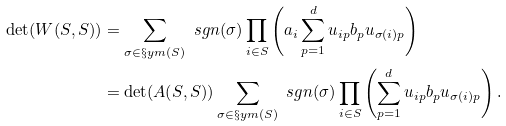Convert formula to latex. <formula><loc_0><loc_0><loc_500><loc_500>\det ( W ( S , S ) ) & = \sum _ { \sigma \in \S y m ( S ) } \ s g n ( \sigma ) \prod _ { i \in S } \left ( a _ { i } \sum _ { p = 1 } ^ { d } u _ { i p } b _ { p } u _ { \sigma ( i ) p } \right ) \\ & = \det ( A ( S , S ) ) \sum _ { \sigma \in \S y m ( S ) } \ s g n ( \sigma ) \prod _ { i \in S } \left ( \sum _ { p = 1 } ^ { d } u _ { i p } b _ { p } u _ { \sigma ( i ) p } \right ) \text {.}</formula> 